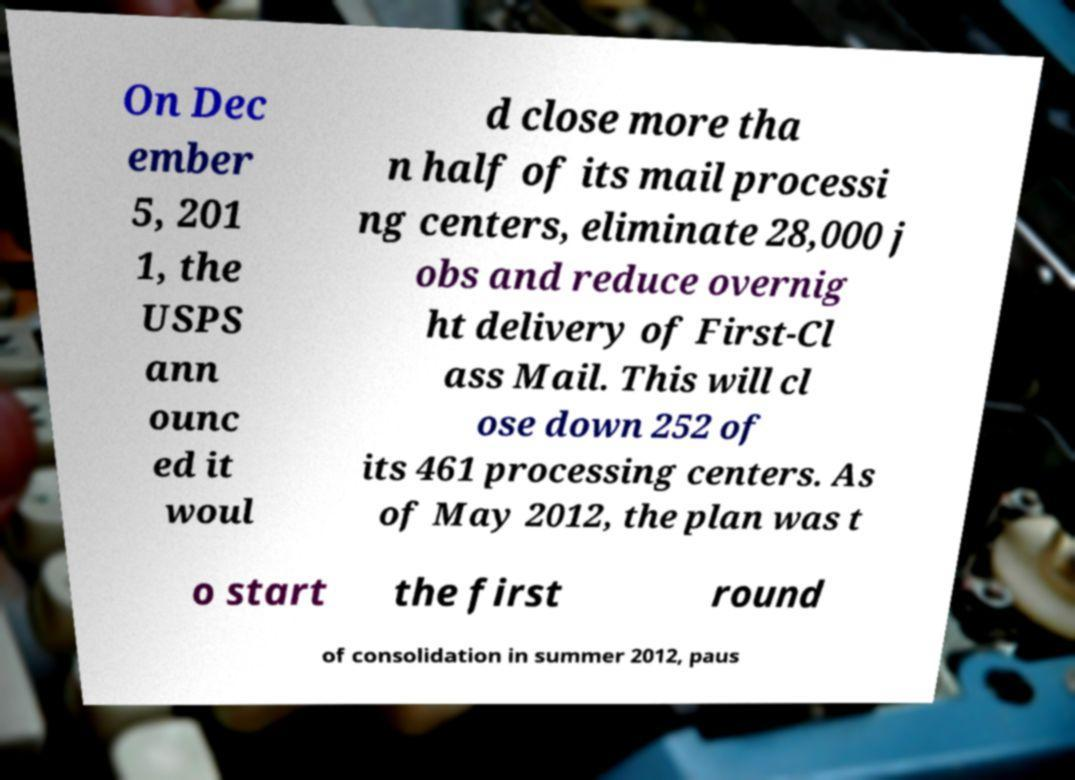Could you assist in decoding the text presented in this image and type it out clearly? On Dec ember 5, 201 1, the USPS ann ounc ed it woul d close more tha n half of its mail processi ng centers, eliminate 28,000 j obs and reduce overnig ht delivery of First-Cl ass Mail. This will cl ose down 252 of its 461 processing centers. As of May 2012, the plan was t o start the first round of consolidation in summer 2012, paus 